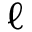Convert formula to latex. <formula><loc_0><loc_0><loc_500><loc_500>\ell</formula> 